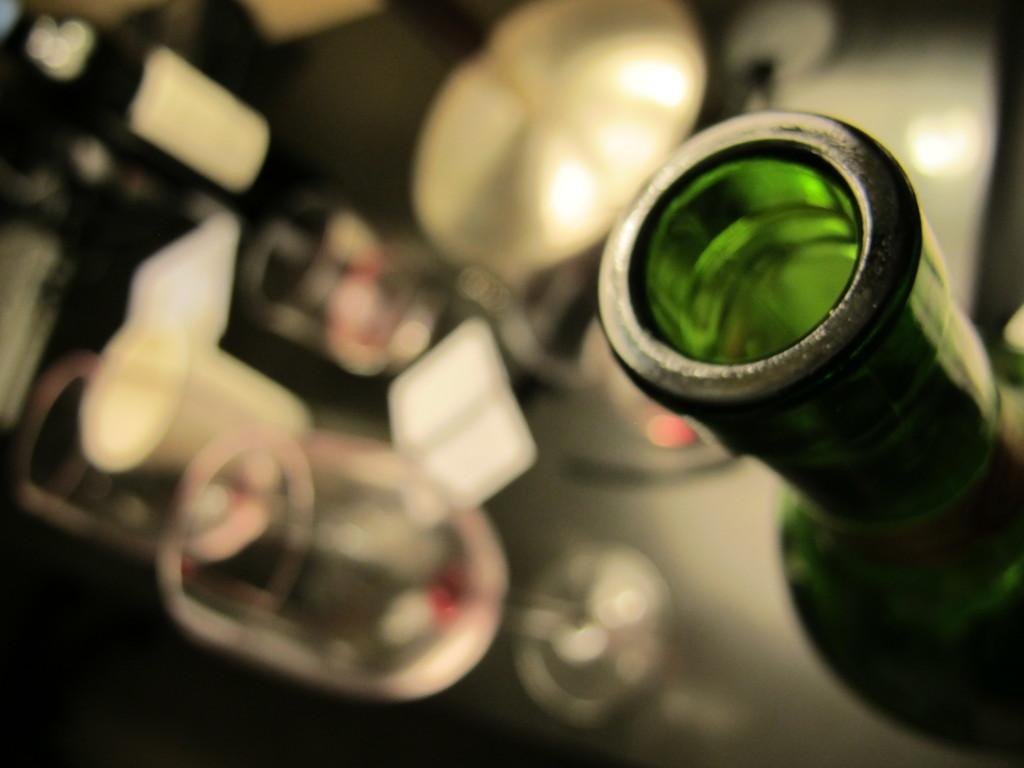Describe this image in one or two sentences. In this picture we can see a bottle and these are the glasses. 